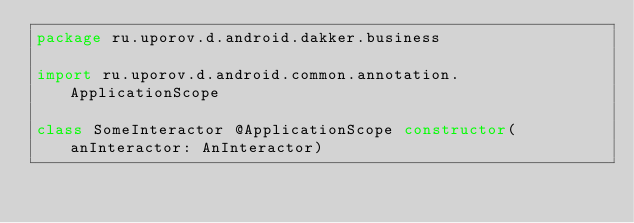<code> <loc_0><loc_0><loc_500><loc_500><_Kotlin_>package ru.uporov.d.android.dakker.business

import ru.uporov.d.android.common.annotation.ApplicationScope

class SomeInteractor @ApplicationScope constructor(anInteractor: AnInteractor)</code> 